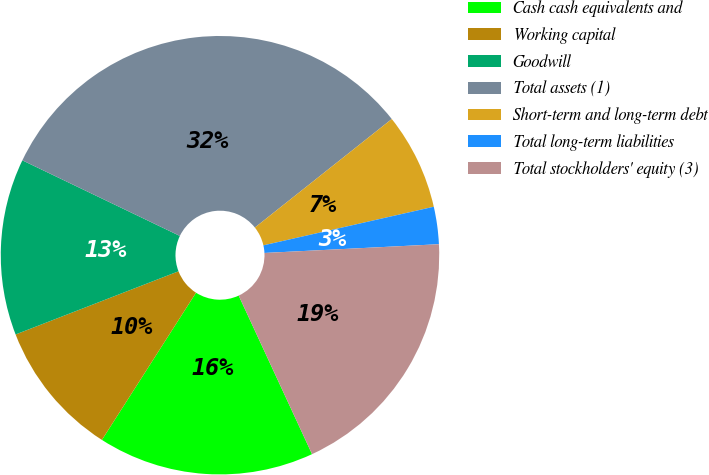Convert chart. <chart><loc_0><loc_0><loc_500><loc_500><pie_chart><fcel>Cash cash equivalents and<fcel>Working capital<fcel>Goodwill<fcel>Total assets (1)<fcel>Short-term and long-term debt<fcel>Total long-term liabilities<fcel>Total stockholders' equity (3)<nl><fcel>15.95%<fcel>10.06%<fcel>13.01%<fcel>32.21%<fcel>7.12%<fcel>2.75%<fcel>18.9%<nl></chart> 